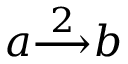<formula> <loc_0><loc_0><loc_500><loc_500>a { \overset { 2 } { \longrightarrow } } b</formula> 